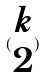Convert formula to latex. <formula><loc_0><loc_0><loc_500><loc_500>( \begin{matrix} k \\ 2 \end{matrix} )</formula> 